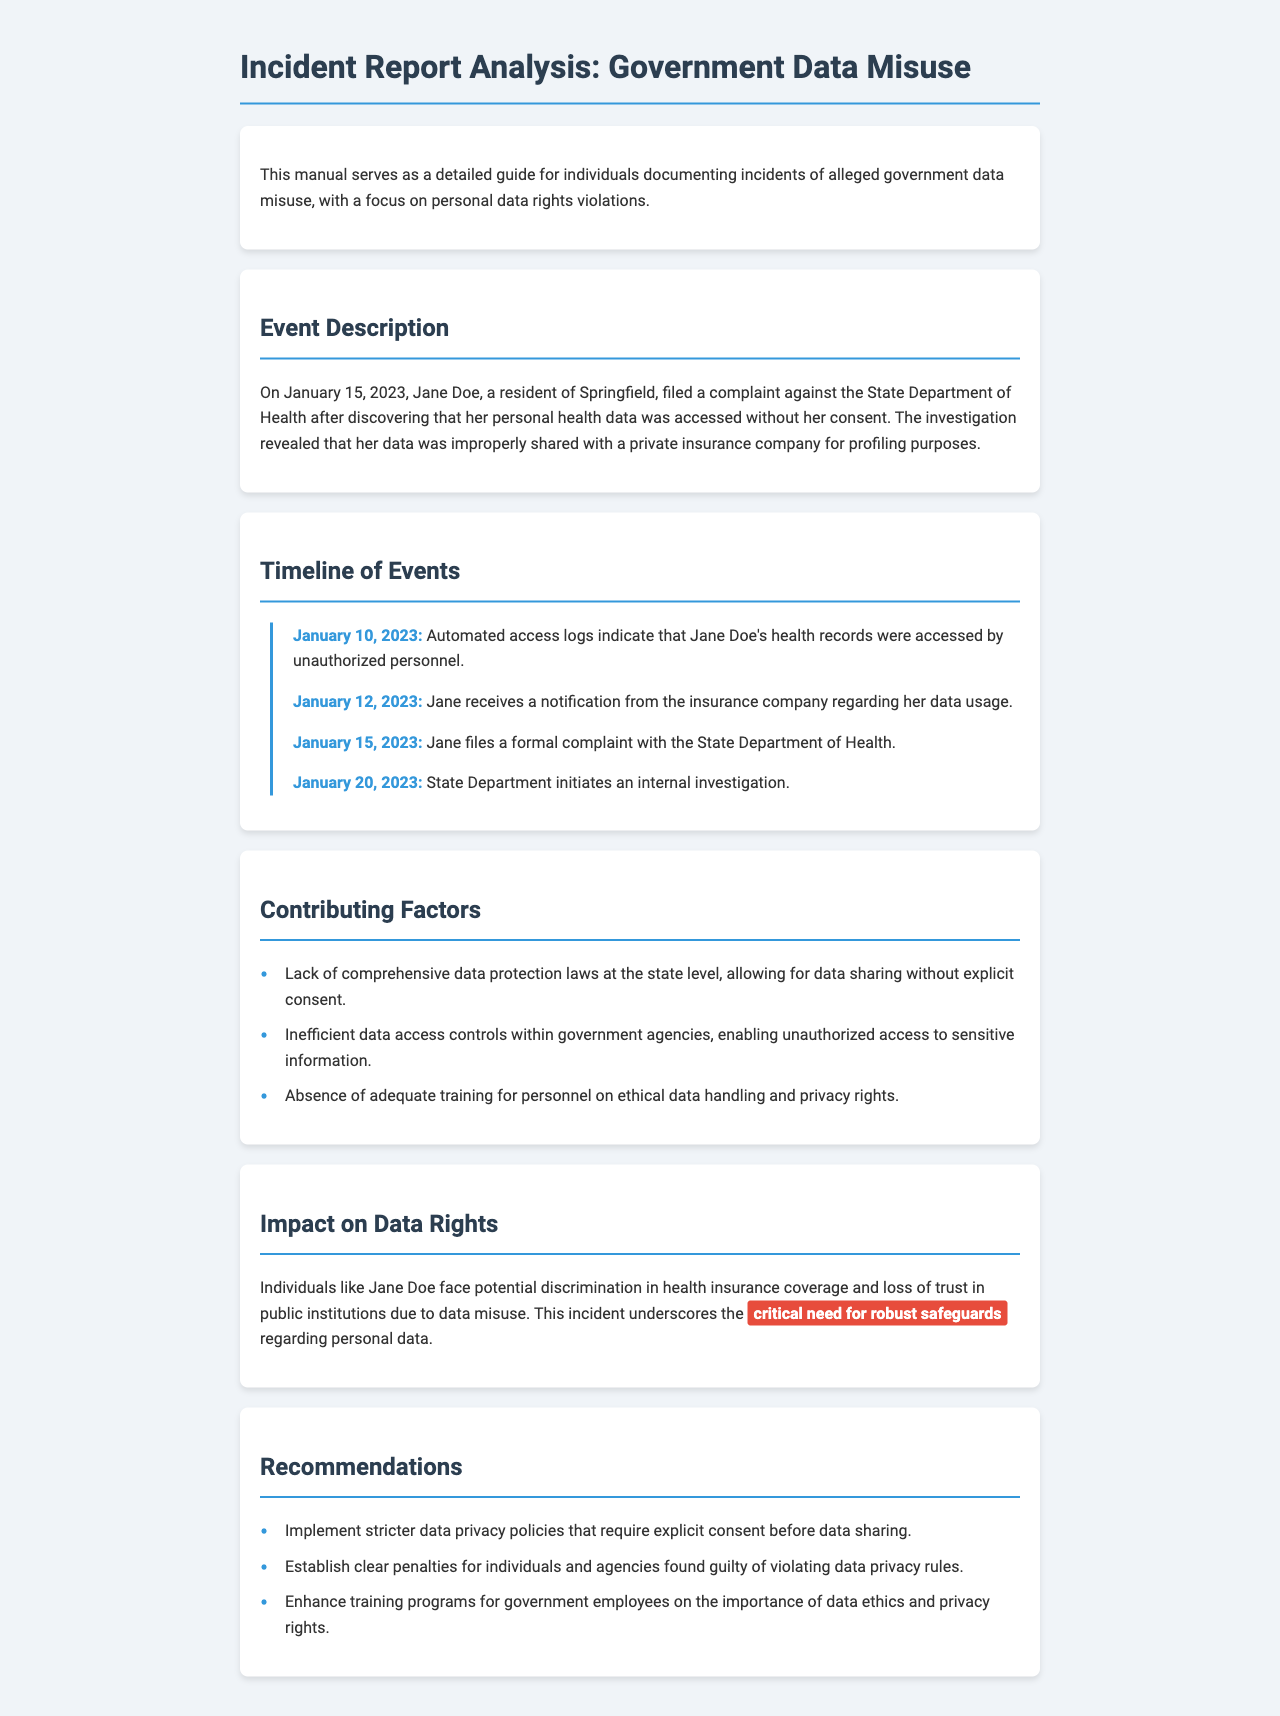What date did Jane Doe file her complaint? The complaint was filed on January 15, 2023, as stated in the Event Description section of the document.
Answer: January 15, 2023 What prompted Jane Doe to file a complaint? The complaint was prompted by her personal health data being accessed without consent, revealed in the Event Description section.
Answer: Accessed without consent How many days passed between unauthorized access and the filing of the complaint? By calculating the timeline dates, unauthorized access was on January 10, 2023, and the complaint was filed on January 15, 2023, making it 5 days.
Answer: 5 days What is one contributing factor to the data misuse? The document lists several contributing factors, and one of them is the lack of comprehensive data protection laws.
Answer: Lack of comprehensive data protection laws What is the highlighted need in the Impact on Data Rights section? The highlighted need in that section states the "critical need for robust safeguards" regarding personal data.
Answer: Critical need for robust safeguards What action does the manual recommend regarding data privacy policies? The manual recommends implementing stricter data privacy policies that require explicit consent before data sharing.
Answer: Explicit consent before data sharing How many timeline events are listed in the document? Counting the events, there are four timeline items presented in the Timeline of Events section.
Answer: Four What organization initiated an internal investigation after the complaint? The State Department, specifically the State Department of Health, initiated the internal investigation as mentioned in the timeline.
Answer: State Department of Health 